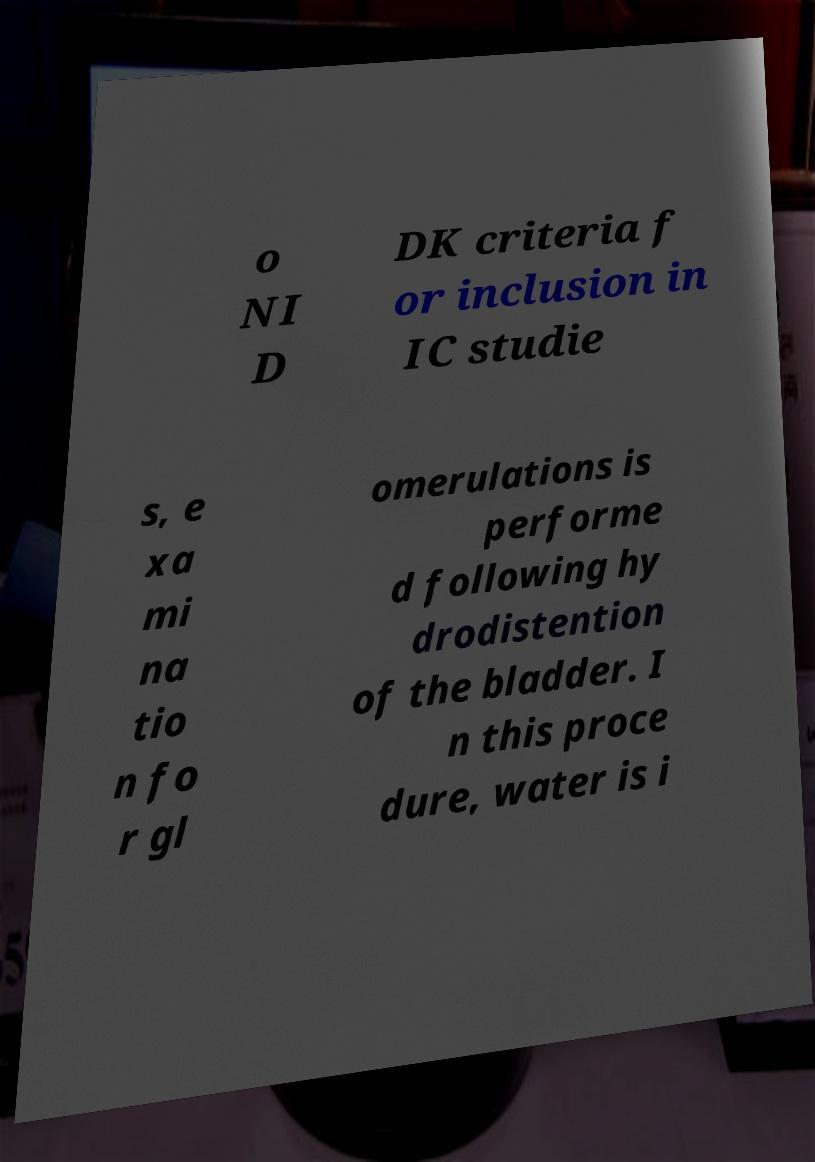For documentation purposes, I need the text within this image transcribed. Could you provide that? o NI D DK criteria f or inclusion in IC studie s, e xa mi na tio n fo r gl omerulations is performe d following hy drodistention of the bladder. I n this proce dure, water is i 